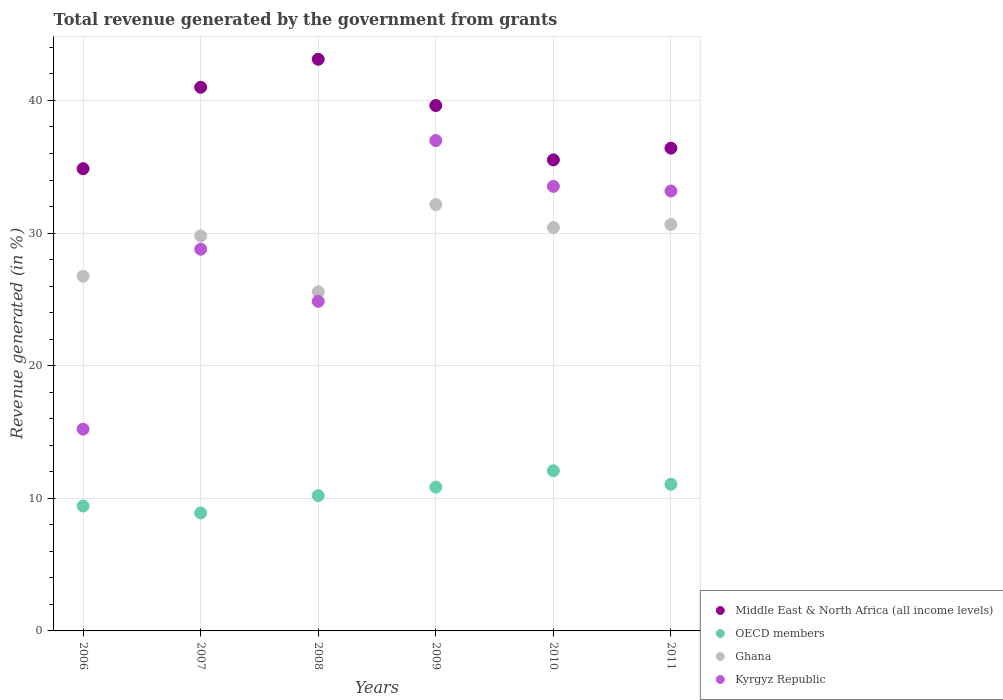How many different coloured dotlines are there?
Provide a short and direct response. 4. What is the total revenue generated in Kyrgyz Republic in 2009?
Your answer should be very brief. 36.97. Across all years, what is the maximum total revenue generated in OECD members?
Offer a very short reply. 12.08. Across all years, what is the minimum total revenue generated in Middle East & North Africa (all income levels)?
Give a very brief answer. 34.85. In which year was the total revenue generated in Ghana maximum?
Give a very brief answer. 2009. What is the total total revenue generated in Kyrgyz Republic in the graph?
Your answer should be compact. 172.52. What is the difference between the total revenue generated in Ghana in 2006 and that in 2007?
Offer a very short reply. -3.04. What is the difference between the total revenue generated in Kyrgyz Republic in 2008 and the total revenue generated in OECD members in 2009?
Your answer should be very brief. 14.01. What is the average total revenue generated in Middle East & North Africa (all income levels) per year?
Provide a succinct answer. 38.41. In the year 2007, what is the difference between the total revenue generated in Kyrgyz Republic and total revenue generated in Middle East & North Africa (all income levels)?
Offer a very short reply. -12.21. In how many years, is the total revenue generated in Kyrgyz Republic greater than 42 %?
Provide a succinct answer. 0. What is the ratio of the total revenue generated in OECD members in 2007 to that in 2011?
Make the answer very short. 0.8. Is the difference between the total revenue generated in Kyrgyz Republic in 2006 and 2010 greater than the difference between the total revenue generated in Middle East & North Africa (all income levels) in 2006 and 2010?
Offer a terse response. No. What is the difference between the highest and the second highest total revenue generated in Ghana?
Give a very brief answer. 1.5. What is the difference between the highest and the lowest total revenue generated in Middle East & North Africa (all income levels)?
Make the answer very short. 8.25. In how many years, is the total revenue generated in Middle East & North Africa (all income levels) greater than the average total revenue generated in Middle East & North Africa (all income levels) taken over all years?
Your answer should be compact. 3. Is the sum of the total revenue generated in OECD members in 2009 and 2011 greater than the maximum total revenue generated in Middle East & North Africa (all income levels) across all years?
Provide a succinct answer. No. Is it the case that in every year, the sum of the total revenue generated in Ghana and total revenue generated in Middle East & North Africa (all income levels)  is greater than the total revenue generated in OECD members?
Ensure brevity in your answer.  Yes. Is the total revenue generated in Ghana strictly greater than the total revenue generated in OECD members over the years?
Give a very brief answer. Yes. How many dotlines are there?
Offer a terse response. 4. How many years are there in the graph?
Make the answer very short. 6. What is the difference between two consecutive major ticks on the Y-axis?
Offer a very short reply. 10. Are the values on the major ticks of Y-axis written in scientific E-notation?
Ensure brevity in your answer.  No. What is the title of the graph?
Offer a very short reply. Total revenue generated by the government from grants. Does "Iceland" appear as one of the legend labels in the graph?
Ensure brevity in your answer.  No. What is the label or title of the X-axis?
Offer a very short reply. Years. What is the label or title of the Y-axis?
Your response must be concise. Revenue generated (in %). What is the Revenue generated (in %) of Middle East & North Africa (all income levels) in 2006?
Ensure brevity in your answer.  34.85. What is the Revenue generated (in %) of OECD members in 2006?
Offer a terse response. 9.41. What is the Revenue generated (in %) of Ghana in 2006?
Make the answer very short. 26.75. What is the Revenue generated (in %) of Kyrgyz Republic in 2006?
Keep it short and to the point. 15.21. What is the Revenue generated (in %) in Middle East & North Africa (all income levels) in 2007?
Your answer should be compact. 40.99. What is the Revenue generated (in %) in OECD members in 2007?
Your answer should be compact. 8.9. What is the Revenue generated (in %) in Ghana in 2007?
Offer a terse response. 29.79. What is the Revenue generated (in %) in Kyrgyz Republic in 2007?
Keep it short and to the point. 28.78. What is the Revenue generated (in %) of Middle East & North Africa (all income levels) in 2008?
Keep it short and to the point. 43.11. What is the Revenue generated (in %) in OECD members in 2008?
Offer a terse response. 10.2. What is the Revenue generated (in %) of Ghana in 2008?
Ensure brevity in your answer.  25.57. What is the Revenue generated (in %) of Kyrgyz Republic in 2008?
Provide a succinct answer. 24.85. What is the Revenue generated (in %) in Middle East & North Africa (all income levels) in 2009?
Provide a short and direct response. 39.62. What is the Revenue generated (in %) in OECD members in 2009?
Keep it short and to the point. 10.84. What is the Revenue generated (in %) in Ghana in 2009?
Give a very brief answer. 32.15. What is the Revenue generated (in %) of Kyrgyz Republic in 2009?
Your response must be concise. 36.97. What is the Revenue generated (in %) of Middle East & North Africa (all income levels) in 2010?
Offer a terse response. 35.52. What is the Revenue generated (in %) of OECD members in 2010?
Make the answer very short. 12.08. What is the Revenue generated (in %) in Ghana in 2010?
Give a very brief answer. 30.42. What is the Revenue generated (in %) of Kyrgyz Republic in 2010?
Make the answer very short. 33.52. What is the Revenue generated (in %) of Middle East & North Africa (all income levels) in 2011?
Provide a succinct answer. 36.4. What is the Revenue generated (in %) in OECD members in 2011?
Provide a succinct answer. 11.06. What is the Revenue generated (in %) in Ghana in 2011?
Provide a short and direct response. 30.65. What is the Revenue generated (in %) in Kyrgyz Republic in 2011?
Offer a terse response. 33.17. Across all years, what is the maximum Revenue generated (in %) of Middle East & North Africa (all income levels)?
Make the answer very short. 43.11. Across all years, what is the maximum Revenue generated (in %) of OECD members?
Give a very brief answer. 12.08. Across all years, what is the maximum Revenue generated (in %) in Ghana?
Provide a succinct answer. 32.15. Across all years, what is the maximum Revenue generated (in %) of Kyrgyz Republic?
Your response must be concise. 36.97. Across all years, what is the minimum Revenue generated (in %) of Middle East & North Africa (all income levels)?
Keep it short and to the point. 34.85. Across all years, what is the minimum Revenue generated (in %) of OECD members?
Keep it short and to the point. 8.9. Across all years, what is the minimum Revenue generated (in %) in Ghana?
Your response must be concise. 25.57. Across all years, what is the minimum Revenue generated (in %) of Kyrgyz Republic?
Your response must be concise. 15.21. What is the total Revenue generated (in %) of Middle East & North Africa (all income levels) in the graph?
Give a very brief answer. 230.49. What is the total Revenue generated (in %) in OECD members in the graph?
Offer a very short reply. 62.49. What is the total Revenue generated (in %) in Ghana in the graph?
Offer a very short reply. 175.32. What is the total Revenue generated (in %) of Kyrgyz Republic in the graph?
Give a very brief answer. 172.52. What is the difference between the Revenue generated (in %) in Middle East & North Africa (all income levels) in 2006 and that in 2007?
Keep it short and to the point. -6.14. What is the difference between the Revenue generated (in %) of OECD members in 2006 and that in 2007?
Provide a succinct answer. 0.51. What is the difference between the Revenue generated (in %) of Ghana in 2006 and that in 2007?
Offer a very short reply. -3.04. What is the difference between the Revenue generated (in %) in Kyrgyz Republic in 2006 and that in 2007?
Offer a very short reply. -13.57. What is the difference between the Revenue generated (in %) of Middle East & North Africa (all income levels) in 2006 and that in 2008?
Give a very brief answer. -8.25. What is the difference between the Revenue generated (in %) in OECD members in 2006 and that in 2008?
Your response must be concise. -0.79. What is the difference between the Revenue generated (in %) of Ghana in 2006 and that in 2008?
Make the answer very short. 1.17. What is the difference between the Revenue generated (in %) of Kyrgyz Republic in 2006 and that in 2008?
Provide a succinct answer. -9.64. What is the difference between the Revenue generated (in %) of Middle East & North Africa (all income levels) in 2006 and that in 2009?
Offer a very short reply. -4.76. What is the difference between the Revenue generated (in %) in OECD members in 2006 and that in 2009?
Your answer should be very brief. -1.43. What is the difference between the Revenue generated (in %) in Ghana in 2006 and that in 2009?
Provide a short and direct response. -5.4. What is the difference between the Revenue generated (in %) in Kyrgyz Republic in 2006 and that in 2009?
Your answer should be very brief. -21.76. What is the difference between the Revenue generated (in %) in Middle East & North Africa (all income levels) in 2006 and that in 2010?
Your answer should be compact. -0.67. What is the difference between the Revenue generated (in %) of OECD members in 2006 and that in 2010?
Your answer should be very brief. -2.66. What is the difference between the Revenue generated (in %) of Ghana in 2006 and that in 2010?
Give a very brief answer. -3.67. What is the difference between the Revenue generated (in %) in Kyrgyz Republic in 2006 and that in 2010?
Your answer should be very brief. -18.31. What is the difference between the Revenue generated (in %) in Middle East & North Africa (all income levels) in 2006 and that in 2011?
Make the answer very short. -1.55. What is the difference between the Revenue generated (in %) in OECD members in 2006 and that in 2011?
Provide a succinct answer. -1.64. What is the difference between the Revenue generated (in %) of Ghana in 2006 and that in 2011?
Your answer should be compact. -3.9. What is the difference between the Revenue generated (in %) in Kyrgyz Republic in 2006 and that in 2011?
Make the answer very short. -17.96. What is the difference between the Revenue generated (in %) of Middle East & North Africa (all income levels) in 2007 and that in 2008?
Make the answer very short. -2.11. What is the difference between the Revenue generated (in %) in OECD members in 2007 and that in 2008?
Your answer should be very brief. -1.3. What is the difference between the Revenue generated (in %) in Ghana in 2007 and that in 2008?
Offer a terse response. 4.21. What is the difference between the Revenue generated (in %) in Kyrgyz Republic in 2007 and that in 2008?
Ensure brevity in your answer.  3.93. What is the difference between the Revenue generated (in %) of Middle East & North Africa (all income levels) in 2007 and that in 2009?
Your answer should be very brief. 1.38. What is the difference between the Revenue generated (in %) of OECD members in 2007 and that in 2009?
Offer a terse response. -1.94. What is the difference between the Revenue generated (in %) in Ghana in 2007 and that in 2009?
Keep it short and to the point. -2.36. What is the difference between the Revenue generated (in %) of Kyrgyz Republic in 2007 and that in 2009?
Give a very brief answer. -8.19. What is the difference between the Revenue generated (in %) in Middle East & North Africa (all income levels) in 2007 and that in 2010?
Keep it short and to the point. 5.47. What is the difference between the Revenue generated (in %) of OECD members in 2007 and that in 2010?
Your response must be concise. -3.18. What is the difference between the Revenue generated (in %) in Ghana in 2007 and that in 2010?
Keep it short and to the point. -0.63. What is the difference between the Revenue generated (in %) of Kyrgyz Republic in 2007 and that in 2010?
Keep it short and to the point. -4.74. What is the difference between the Revenue generated (in %) in Middle East & North Africa (all income levels) in 2007 and that in 2011?
Keep it short and to the point. 4.59. What is the difference between the Revenue generated (in %) of OECD members in 2007 and that in 2011?
Keep it short and to the point. -2.16. What is the difference between the Revenue generated (in %) of Ghana in 2007 and that in 2011?
Provide a succinct answer. -0.86. What is the difference between the Revenue generated (in %) in Kyrgyz Republic in 2007 and that in 2011?
Your answer should be very brief. -4.39. What is the difference between the Revenue generated (in %) in Middle East & North Africa (all income levels) in 2008 and that in 2009?
Ensure brevity in your answer.  3.49. What is the difference between the Revenue generated (in %) of OECD members in 2008 and that in 2009?
Provide a succinct answer. -0.64. What is the difference between the Revenue generated (in %) of Ghana in 2008 and that in 2009?
Your response must be concise. -6.57. What is the difference between the Revenue generated (in %) in Kyrgyz Republic in 2008 and that in 2009?
Your response must be concise. -12.12. What is the difference between the Revenue generated (in %) in Middle East & North Africa (all income levels) in 2008 and that in 2010?
Offer a very short reply. 7.59. What is the difference between the Revenue generated (in %) in OECD members in 2008 and that in 2010?
Offer a very short reply. -1.88. What is the difference between the Revenue generated (in %) of Ghana in 2008 and that in 2010?
Your answer should be very brief. -4.84. What is the difference between the Revenue generated (in %) in Kyrgyz Republic in 2008 and that in 2010?
Ensure brevity in your answer.  -8.67. What is the difference between the Revenue generated (in %) of Middle East & North Africa (all income levels) in 2008 and that in 2011?
Provide a succinct answer. 6.7. What is the difference between the Revenue generated (in %) of OECD members in 2008 and that in 2011?
Provide a succinct answer. -0.86. What is the difference between the Revenue generated (in %) of Ghana in 2008 and that in 2011?
Provide a short and direct response. -5.07. What is the difference between the Revenue generated (in %) of Kyrgyz Republic in 2008 and that in 2011?
Give a very brief answer. -8.32. What is the difference between the Revenue generated (in %) of Middle East & North Africa (all income levels) in 2009 and that in 2010?
Ensure brevity in your answer.  4.1. What is the difference between the Revenue generated (in %) in OECD members in 2009 and that in 2010?
Offer a terse response. -1.24. What is the difference between the Revenue generated (in %) of Ghana in 2009 and that in 2010?
Give a very brief answer. 1.73. What is the difference between the Revenue generated (in %) of Kyrgyz Republic in 2009 and that in 2010?
Your response must be concise. 3.45. What is the difference between the Revenue generated (in %) in Middle East & North Africa (all income levels) in 2009 and that in 2011?
Keep it short and to the point. 3.21. What is the difference between the Revenue generated (in %) of OECD members in 2009 and that in 2011?
Your answer should be very brief. -0.22. What is the difference between the Revenue generated (in %) in Ghana in 2009 and that in 2011?
Offer a very short reply. 1.5. What is the difference between the Revenue generated (in %) in Kyrgyz Republic in 2009 and that in 2011?
Provide a short and direct response. 3.8. What is the difference between the Revenue generated (in %) in Middle East & North Africa (all income levels) in 2010 and that in 2011?
Offer a terse response. -0.88. What is the difference between the Revenue generated (in %) of OECD members in 2010 and that in 2011?
Provide a succinct answer. 1.02. What is the difference between the Revenue generated (in %) of Ghana in 2010 and that in 2011?
Your answer should be very brief. -0.23. What is the difference between the Revenue generated (in %) of Kyrgyz Republic in 2010 and that in 2011?
Ensure brevity in your answer.  0.35. What is the difference between the Revenue generated (in %) of Middle East & North Africa (all income levels) in 2006 and the Revenue generated (in %) of OECD members in 2007?
Your response must be concise. 25.95. What is the difference between the Revenue generated (in %) of Middle East & North Africa (all income levels) in 2006 and the Revenue generated (in %) of Ghana in 2007?
Offer a very short reply. 5.07. What is the difference between the Revenue generated (in %) of Middle East & North Africa (all income levels) in 2006 and the Revenue generated (in %) of Kyrgyz Republic in 2007?
Offer a very short reply. 6.07. What is the difference between the Revenue generated (in %) of OECD members in 2006 and the Revenue generated (in %) of Ghana in 2007?
Ensure brevity in your answer.  -20.37. What is the difference between the Revenue generated (in %) in OECD members in 2006 and the Revenue generated (in %) in Kyrgyz Republic in 2007?
Give a very brief answer. -19.37. What is the difference between the Revenue generated (in %) in Ghana in 2006 and the Revenue generated (in %) in Kyrgyz Republic in 2007?
Your response must be concise. -2.04. What is the difference between the Revenue generated (in %) of Middle East & North Africa (all income levels) in 2006 and the Revenue generated (in %) of OECD members in 2008?
Ensure brevity in your answer.  24.65. What is the difference between the Revenue generated (in %) of Middle East & North Africa (all income levels) in 2006 and the Revenue generated (in %) of Ghana in 2008?
Your answer should be very brief. 9.28. What is the difference between the Revenue generated (in %) of Middle East & North Africa (all income levels) in 2006 and the Revenue generated (in %) of Kyrgyz Republic in 2008?
Your answer should be compact. 10. What is the difference between the Revenue generated (in %) of OECD members in 2006 and the Revenue generated (in %) of Ghana in 2008?
Your answer should be compact. -16.16. What is the difference between the Revenue generated (in %) in OECD members in 2006 and the Revenue generated (in %) in Kyrgyz Republic in 2008?
Offer a terse response. -15.44. What is the difference between the Revenue generated (in %) of Ghana in 2006 and the Revenue generated (in %) of Kyrgyz Republic in 2008?
Provide a short and direct response. 1.9. What is the difference between the Revenue generated (in %) in Middle East & North Africa (all income levels) in 2006 and the Revenue generated (in %) in OECD members in 2009?
Make the answer very short. 24.01. What is the difference between the Revenue generated (in %) of Middle East & North Africa (all income levels) in 2006 and the Revenue generated (in %) of Ghana in 2009?
Make the answer very short. 2.71. What is the difference between the Revenue generated (in %) in Middle East & North Africa (all income levels) in 2006 and the Revenue generated (in %) in Kyrgyz Republic in 2009?
Ensure brevity in your answer.  -2.12. What is the difference between the Revenue generated (in %) of OECD members in 2006 and the Revenue generated (in %) of Ghana in 2009?
Make the answer very short. -22.73. What is the difference between the Revenue generated (in %) in OECD members in 2006 and the Revenue generated (in %) in Kyrgyz Republic in 2009?
Provide a succinct answer. -27.56. What is the difference between the Revenue generated (in %) of Ghana in 2006 and the Revenue generated (in %) of Kyrgyz Republic in 2009?
Your answer should be very brief. -10.23. What is the difference between the Revenue generated (in %) of Middle East & North Africa (all income levels) in 2006 and the Revenue generated (in %) of OECD members in 2010?
Make the answer very short. 22.78. What is the difference between the Revenue generated (in %) in Middle East & North Africa (all income levels) in 2006 and the Revenue generated (in %) in Ghana in 2010?
Offer a terse response. 4.44. What is the difference between the Revenue generated (in %) of Middle East & North Africa (all income levels) in 2006 and the Revenue generated (in %) of Kyrgyz Republic in 2010?
Ensure brevity in your answer.  1.33. What is the difference between the Revenue generated (in %) in OECD members in 2006 and the Revenue generated (in %) in Ghana in 2010?
Provide a short and direct response. -21. What is the difference between the Revenue generated (in %) of OECD members in 2006 and the Revenue generated (in %) of Kyrgyz Republic in 2010?
Give a very brief answer. -24.11. What is the difference between the Revenue generated (in %) in Ghana in 2006 and the Revenue generated (in %) in Kyrgyz Republic in 2010?
Offer a terse response. -6.77. What is the difference between the Revenue generated (in %) of Middle East & North Africa (all income levels) in 2006 and the Revenue generated (in %) of OECD members in 2011?
Offer a terse response. 23.8. What is the difference between the Revenue generated (in %) of Middle East & North Africa (all income levels) in 2006 and the Revenue generated (in %) of Ghana in 2011?
Your response must be concise. 4.21. What is the difference between the Revenue generated (in %) of Middle East & North Africa (all income levels) in 2006 and the Revenue generated (in %) of Kyrgyz Republic in 2011?
Provide a short and direct response. 1.68. What is the difference between the Revenue generated (in %) in OECD members in 2006 and the Revenue generated (in %) in Ghana in 2011?
Offer a terse response. -21.23. What is the difference between the Revenue generated (in %) of OECD members in 2006 and the Revenue generated (in %) of Kyrgyz Republic in 2011?
Give a very brief answer. -23.76. What is the difference between the Revenue generated (in %) of Ghana in 2006 and the Revenue generated (in %) of Kyrgyz Republic in 2011?
Your response must be concise. -6.43. What is the difference between the Revenue generated (in %) of Middle East & North Africa (all income levels) in 2007 and the Revenue generated (in %) of OECD members in 2008?
Ensure brevity in your answer.  30.79. What is the difference between the Revenue generated (in %) of Middle East & North Africa (all income levels) in 2007 and the Revenue generated (in %) of Ghana in 2008?
Offer a very short reply. 15.42. What is the difference between the Revenue generated (in %) in Middle East & North Africa (all income levels) in 2007 and the Revenue generated (in %) in Kyrgyz Republic in 2008?
Provide a succinct answer. 16.14. What is the difference between the Revenue generated (in %) in OECD members in 2007 and the Revenue generated (in %) in Ghana in 2008?
Your response must be concise. -16.68. What is the difference between the Revenue generated (in %) of OECD members in 2007 and the Revenue generated (in %) of Kyrgyz Republic in 2008?
Ensure brevity in your answer.  -15.95. What is the difference between the Revenue generated (in %) of Ghana in 2007 and the Revenue generated (in %) of Kyrgyz Republic in 2008?
Offer a terse response. 4.94. What is the difference between the Revenue generated (in %) in Middle East & North Africa (all income levels) in 2007 and the Revenue generated (in %) in OECD members in 2009?
Give a very brief answer. 30.15. What is the difference between the Revenue generated (in %) of Middle East & North Africa (all income levels) in 2007 and the Revenue generated (in %) of Ghana in 2009?
Your response must be concise. 8.85. What is the difference between the Revenue generated (in %) of Middle East & North Africa (all income levels) in 2007 and the Revenue generated (in %) of Kyrgyz Republic in 2009?
Ensure brevity in your answer.  4.02. What is the difference between the Revenue generated (in %) of OECD members in 2007 and the Revenue generated (in %) of Ghana in 2009?
Provide a succinct answer. -23.25. What is the difference between the Revenue generated (in %) of OECD members in 2007 and the Revenue generated (in %) of Kyrgyz Republic in 2009?
Your answer should be compact. -28.08. What is the difference between the Revenue generated (in %) of Ghana in 2007 and the Revenue generated (in %) of Kyrgyz Republic in 2009?
Your answer should be very brief. -7.19. What is the difference between the Revenue generated (in %) of Middle East & North Africa (all income levels) in 2007 and the Revenue generated (in %) of OECD members in 2010?
Offer a terse response. 28.91. What is the difference between the Revenue generated (in %) in Middle East & North Africa (all income levels) in 2007 and the Revenue generated (in %) in Ghana in 2010?
Make the answer very short. 10.58. What is the difference between the Revenue generated (in %) in Middle East & North Africa (all income levels) in 2007 and the Revenue generated (in %) in Kyrgyz Republic in 2010?
Your answer should be very brief. 7.47. What is the difference between the Revenue generated (in %) in OECD members in 2007 and the Revenue generated (in %) in Ghana in 2010?
Your answer should be very brief. -21.52. What is the difference between the Revenue generated (in %) of OECD members in 2007 and the Revenue generated (in %) of Kyrgyz Republic in 2010?
Ensure brevity in your answer.  -24.62. What is the difference between the Revenue generated (in %) of Ghana in 2007 and the Revenue generated (in %) of Kyrgyz Republic in 2010?
Your response must be concise. -3.73. What is the difference between the Revenue generated (in %) in Middle East & North Africa (all income levels) in 2007 and the Revenue generated (in %) in OECD members in 2011?
Keep it short and to the point. 29.94. What is the difference between the Revenue generated (in %) of Middle East & North Africa (all income levels) in 2007 and the Revenue generated (in %) of Ghana in 2011?
Provide a succinct answer. 10.35. What is the difference between the Revenue generated (in %) in Middle East & North Africa (all income levels) in 2007 and the Revenue generated (in %) in Kyrgyz Republic in 2011?
Keep it short and to the point. 7.82. What is the difference between the Revenue generated (in %) in OECD members in 2007 and the Revenue generated (in %) in Ghana in 2011?
Offer a very short reply. -21.75. What is the difference between the Revenue generated (in %) of OECD members in 2007 and the Revenue generated (in %) of Kyrgyz Republic in 2011?
Provide a succinct answer. -24.27. What is the difference between the Revenue generated (in %) of Ghana in 2007 and the Revenue generated (in %) of Kyrgyz Republic in 2011?
Your response must be concise. -3.39. What is the difference between the Revenue generated (in %) in Middle East & North Africa (all income levels) in 2008 and the Revenue generated (in %) in OECD members in 2009?
Your answer should be compact. 32.26. What is the difference between the Revenue generated (in %) in Middle East & North Africa (all income levels) in 2008 and the Revenue generated (in %) in Ghana in 2009?
Make the answer very short. 10.96. What is the difference between the Revenue generated (in %) of Middle East & North Africa (all income levels) in 2008 and the Revenue generated (in %) of Kyrgyz Republic in 2009?
Keep it short and to the point. 6.13. What is the difference between the Revenue generated (in %) of OECD members in 2008 and the Revenue generated (in %) of Ghana in 2009?
Your answer should be compact. -21.95. What is the difference between the Revenue generated (in %) in OECD members in 2008 and the Revenue generated (in %) in Kyrgyz Republic in 2009?
Provide a succinct answer. -26.77. What is the difference between the Revenue generated (in %) in Ghana in 2008 and the Revenue generated (in %) in Kyrgyz Republic in 2009?
Provide a succinct answer. -11.4. What is the difference between the Revenue generated (in %) in Middle East & North Africa (all income levels) in 2008 and the Revenue generated (in %) in OECD members in 2010?
Your answer should be very brief. 31.03. What is the difference between the Revenue generated (in %) of Middle East & North Africa (all income levels) in 2008 and the Revenue generated (in %) of Ghana in 2010?
Offer a very short reply. 12.69. What is the difference between the Revenue generated (in %) in Middle East & North Africa (all income levels) in 2008 and the Revenue generated (in %) in Kyrgyz Republic in 2010?
Your answer should be very brief. 9.58. What is the difference between the Revenue generated (in %) in OECD members in 2008 and the Revenue generated (in %) in Ghana in 2010?
Your answer should be compact. -20.22. What is the difference between the Revenue generated (in %) of OECD members in 2008 and the Revenue generated (in %) of Kyrgyz Republic in 2010?
Your response must be concise. -23.32. What is the difference between the Revenue generated (in %) in Ghana in 2008 and the Revenue generated (in %) in Kyrgyz Republic in 2010?
Your answer should be very brief. -7.95. What is the difference between the Revenue generated (in %) of Middle East & North Africa (all income levels) in 2008 and the Revenue generated (in %) of OECD members in 2011?
Make the answer very short. 32.05. What is the difference between the Revenue generated (in %) of Middle East & North Africa (all income levels) in 2008 and the Revenue generated (in %) of Ghana in 2011?
Keep it short and to the point. 12.46. What is the difference between the Revenue generated (in %) of Middle East & North Africa (all income levels) in 2008 and the Revenue generated (in %) of Kyrgyz Republic in 2011?
Your response must be concise. 9.93. What is the difference between the Revenue generated (in %) of OECD members in 2008 and the Revenue generated (in %) of Ghana in 2011?
Your answer should be compact. -20.45. What is the difference between the Revenue generated (in %) in OECD members in 2008 and the Revenue generated (in %) in Kyrgyz Republic in 2011?
Provide a succinct answer. -22.97. What is the difference between the Revenue generated (in %) in Ghana in 2008 and the Revenue generated (in %) in Kyrgyz Republic in 2011?
Offer a very short reply. -7.6. What is the difference between the Revenue generated (in %) in Middle East & North Africa (all income levels) in 2009 and the Revenue generated (in %) in OECD members in 2010?
Your answer should be very brief. 27.54. What is the difference between the Revenue generated (in %) in Middle East & North Africa (all income levels) in 2009 and the Revenue generated (in %) in Ghana in 2010?
Your response must be concise. 9.2. What is the difference between the Revenue generated (in %) of Middle East & North Africa (all income levels) in 2009 and the Revenue generated (in %) of Kyrgyz Republic in 2010?
Offer a terse response. 6.09. What is the difference between the Revenue generated (in %) in OECD members in 2009 and the Revenue generated (in %) in Ghana in 2010?
Offer a very short reply. -19.58. What is the difference between the Revenue generated (in %) in OECD members in 2009 and the Revenue generated (in %) in Kyrgyz Republic in 2010?
Ensure brevity in your answer.  -22.68. What is the difference between the Revenue generated (in %) in Ghana in 2009 and the Revenue generated (in %) in Kyrgyz Republic in 2010?
Provide a short and direct response. -1.37. What is the difference between the Revenue generated (in %) of Middle East & North Africa (all income levels) in 2009 and the Revenue generated (in %) of OECD members in 2011?
Your answer should be compact. 28.56. What is the difference between the Revenue generated (in %) in Middle East & North Africa (all income levels) in 2009 and the Revenue generated (in %) in Ghana in 2011?
Your answer should be compact. 8.97. What is the difference between the Revenue generated (in %) of Middle East & North Africa (all income levels) in 2009 and the Revenue generated (in %) of Kyrgyz Republic in 2011?
Provide a short and direct response. 6.44. What is the difference between the Revenue generated (in %) in OECD members in 2009 and the Revenue generated (in %) in Ghana in 2011?
Provide a succinct answer. -19.81. What is the difference between the Revenue generated (in %) of OECD members in 2009 and the Revenue generated (in %) of Kyrgyz Republic in 2011?
Make the answer very short. -22.33. What is the difference between the Revenue generated (in %) in Ghana in 2009 and the Revenue generated (in %) in Kyrgyz Republic in 2011?
Give a very brief answer. -1.03. What is the difference between the Revenue generated (in %) of Middle East & North Africa (all income levels) in 2010 and the Revenue generated (in %) of OECD members in 2011?
Your answer should be very brief. 24.46. What is the difference between the Revenue generated (in %) in Middle East & North Africa (all income levels) in 2010 and the Revenue generated (in %) in Ghana in 2011?
Offer a terse response. 4.87. What is the difference between the Revenue generated (in %) of Middle East & North Africa (all income levels) in 2010 and the Revenue generated (in %) of Kyrgyz Republic in 2011?
Keep it short and to the point. 2.35. What is the difference between the Revenue generated (in %) in OECD members in 2010 and the Revenue generated (in %) in Ghana in 2011?
Make the answer very short. -18.57. What is the difference between the Revenue generated (in %) in OECD members in 2010 and the Revenue generated (in %) in Kyrgyz Republic in 2011?
Give a very brief answer. -21.1. What is the difference between the Revenue generated (in %) of Ghana in 2010 and the Revenue generated (in %) of Kyrgyz Republic in 2011?
Give a very brief answer. -2.76. What is the average Revenue generated (in %) of Middle East & North Africa (all income levels) per year?
Keep it short and to the point. 38.41. What is the average Revenue generated (in %) in OECD members per year?
Provide a succinct answer. 10.41. What is the average Revenue generated (in %) in Ghana per year?
Keep it short and to the point. 29.22. What is the average Revenue generated (in %) of Kyrgyz Republic per year?
Give a very brief answer. 28.75. In the year 2006, what is the difference between the Revenue generated (in %) in Middle East & North Africa (all income levels) and Revenue generated (in %) in OECD members?
Provide a succinct answer. 25.44. In the year 2006, what is the difference between the Revenue generated (in %) of Middle East & North Africa (all income levels) and Revenue generated (in %) of Ghana?
Offer a terse response. 8.11. In the year 2006, what is the difference between the Revenue generated (in %) in Middle East & North Africa (all income levels) and Revenue generated (in %) in Kyrgyz Republic?
Provide a succinct answer. 19.64. In the year 2006, what is the difference between the Revenue generated (in %) in OECD members and Revenue generated (in %) in Ghana?
Provide a succinct answer. -17.33. In the year 2006, what is the difference between the Revenue generated (in %) of OECD members and Revenue generated (in %) of Kyrgyz Republic?
Make the answer very short. -5.8. In the year 2006, what is the difference between the Revenue generated (in %) of Ghana and Revenue generated (in %) of Kyrgyz Republic?
Ensure brevity in your answer.  11.53. In the year 2007, what is the difference between the Revenue generated (in %) in Middle East & North Africa (all income levels) and Revenue generated (in %) in OECD members?
Your response must be concise. 32.09. In the year 2007, what is the difference between the Revenue generated (in %) of Middle East & North Africa (all income levels) and Revenue generated (in %) of Ghana?
Offer a terse response. 11.21. In the year 2007, what is the difference between the Revenue generated (in %) in Middle East & North Africa (all income levels) and Revenue generated (in %) in Kyrgyz Republic?
Offer a terse response. 12.21. In the year 2007, what is the difference between the Revenue generated (in %) in OECD members and Revenue generated (in %) in Ghana?
Your response must be concise. -20.89. In the year 2007, what is the difference between the Revenue generated (in %) in OECD members and Revenue generated (in %) in Kyrgyz Republic?
Your answer should be compact. -19.89. In the year 2008, what is the difference between the Revenue generated (in %) in Middle East & North Africa (all income levels) and Revenue generated (in %) in OECD members?
Make the answer very short. 32.9. In the year 2008, what is the difference between the Revenue generated (in %) of Middle East & North Africa (all income levels) and Revenue generated (in %) of Ghana?
Your response must be concise. 17.53. In the year 2008, what is the difference between the Revenue generated (in %) of Middle East & North Africa (all income levels) and Revenue generated (in %) of Kyrgyz Republic?
Make the answer very short. 18.25. In the year 2008, what is the difference between the Revenue generated (in %) in OECD members and Revenue generated (in %) in Ghana?
Your answer should be very brief. -15.37. In the year 2008, what is the difference between the Revenue generated (in %) of OECD members and Revenue generated (in %) of Kyrgyz Republic?
Your response must be concise. -14.65. In the year 2008, what is the difference between the Revenue generated (in %) in Ghana and Revenue generated (in %) in Kyrgyz Republic?
Ensure brevity in your answer.  0.72. In the year 2009, what is the difference between the Revenue generated (in %) in Middle East & North Africa (all income levels) and Revenue generated (in %) in OECD members?
Your answer should be very brief. 28.78. In the year 2009, what is the difference between the Revenue generated (in %) of Middle East & North Africa (all income levels) and Revenue generated (in %) of Ghana?
Provide a succinct answer. 7.47. In the year 2009, what is the difference between the Revenue generated (in %) in Middle East & North Africa (all income levels) and Revenue generated (in %) in Kyrgyz Republic?
Your answer should be compact. 2.64. In the year 2009, what is the difference between the Revenue generated (in %) in OECD members and Revenue generated (in %) in Ghana?
Provide a short and direct response. -21.31. In the year 2009, what is the difference between the Revenue generated (in %) in OECD members and Revenue generated (in %) in Kyrgyz Republic?
Provide a succinct answer. -26.13. In the year 2009, what is the difference between the Revenue generated (in %) of Ghana and Revenue generated (in %) of Kyrgyz Republic?
Give a very brief answer. -4.83. In the year 2010, what is the difference between the Revenue generated (in %) of Middle East & North Africa (all income levels) and Revenue generated (in %) of OECD members?
Offer a terse response. 23.44. In the year 2010, what is the difference between the Revenue generated (in %) of Middle East & North Africa (all income levels) and Revenue generated (in %) of Ghana?
Provide a short and direct response. 5.1. In the year 2010, what is the difference between the Revenue generated (in %) of Middle East & North Africa (all income levels) and Revenue generated (in %) of Kyrgyz Republic?
Your answer should be very brief. 2. In the year 2010, what is the difference between the Revenue generated (in %) in OECD members and Revenue generated (in %) in Ghana?
Keep it short and to the point. -18.34. In the year 2010, what is the difference between the Revenue generated (in %) of OECD members and Revenue generated (in %) of Kyrgyz Republic?
Make the answer very short. -21.44. In the year 2010, what is the difference between the Revenue generated (in %) in Ghana and Revenue generated (in %) in Kyrgyz Republic?
Provide a succinct answer. -3.1. In the year 2011, what is the difference between the Revenue generated (in %) in Middle East & North Africa (all income levels) and Revenue generated (in %) in OECD members?
Provide a short and direct response. 25.35. In the year 2011, what is the difference between the Revenue generated (in %) of Middle East & North Africa (all income levels) and Revenue generated (in %) of Ghana?
Your answer should be compact. 5.76. In the year 2011, what is the difference between the Revenue generated (in %) of Middle East & North Africa (all income levels) and Revenue generated (in %) of Kyrgyz Republic?
Your answer should be very brief. 3.23. In the year 2011, what is the difference between the Revenue generated (in %) in OECD members and Revenue generated (in %) in Ghana?
Keep it short and to the point. -19.59. In the year 2011, what is the difference between the Revenue generated (in %) in OECD members and Revenue generated (in %) in Kyrgyz Republic?
Keep it short and to the point. -22.12. In the year 2011, what is the difference between the Revenue generated (in %) in Ghana and Revenue generated (in %) in Kyrgyz Republic?
Offer a very short reply. -2.53. What is the ratio of the Revenue generated (in %) of Middle East & North Africa (all income levels) in 2006 to that in 2007?
Keep it short and to the point. 0.85. What is the ratio of the Revenue generated (in %) in OECD members in 2006 to that in 2007?
Provide a succinct answer. 1.06. What is the ratio of the Revenue generated (in %) in Ghana in 2006 to that in 2007?
Your response must be concise. 0.9. What is the ratio of the Revenue generated (in %) in Kyrgyz Republic in 2006 to that in 2007?
Keep it short and to the point. 0.53. What is the ratio of the Revenue generated (in %) in Middle East & North Africa (all income levels) in 2006 to that in 2008?
Offer a very short reply. 0.81. What is the ratio of the Revenue generated (in %) in OECD members in 2006 to that in 2008?
Keep it short and to the point. 0.92. What is the ratio of the Revenue generated (in %) in Ghana in 2006 to that in 2008?
Keep it short and to the point. 1.05. What is the ratio of the Revenue generated (in %) in Kyrgyz Republic in 2006 to that in 2008?
Your answer should be very brief. 0.61. What is the ratio of the Revenue generated (in %) of Middle East & North Africa (all income levels) in 2006 to that in 2009?
Your response must be concise. 0.88. What is the ratio of the Revenue generated (in %) in OECD members in 2006 to that in 2009?
Offer a very short reply. 0.87. What is the ratio of the Revenue generated (in %) of Ghana in 2006 to that in 2009?
Provide a short and direct response. 0.83. What is the ratio of the Revenue generated (in %) in Kyrgyz Republic in 2006 to that in 2009?
Provide a short and direct response. 0.41. What is the ratio of the Revenue generated (in %) in Middle East & North Africa (all income levels) in 2006 to that in 2010?
Your response must be concise. 0.98. What is the ratio of the Revenue generated (in %) of OECD members in 2006 to that in 2010?
Offer a terse response. 0.78. What is the ratio of the Revenue generated (in %) in Ghana in 2006 to that in 2010?
Give a very brief answer. 0.88. What is the ratio of the Revenue generated (in %) of Kyrgyz Republic in 2006 to that in 2010?
Provide a succinct answer. 0.45. What is the ratio of the Revenue generated (in %) in Middle East & North Africa (all income levels) in 2006 to that in 2011?
Keep it short and to the point. 0.96. What is the ratio of the Revenue generated (in %) of OECD members in 2006 to that in 2011?
Give a very brief answer. 0.85. What is the ratio of the Revenue generated (in %) in Ghana in 2006 to that in 2011?
Provide a short and direct response. 0.87. What is the ratio of the Revenue generated (in %) in Kyrgyz Republic in 2006 to that in 2011?
Offer a terse response. 0.46. What is the ratio of the Revenue generated (in %) in Middle East & North Africa (all income levels) in 2007 to that in 2008?
Your answer should be compact. 0.95. What is the ratio of the Revenue generated (in %) in OECD members in 2007 to that in 2008?
Offer a terse response. 0.87. What is the ratio of the Revenue generated (in %) in Ghana in 2007 to that in 2008?
Your response must be concise. 1.16. What is the ratio of the Revenue generated (in %) in Kyrgyz Republic in 2007 to that in 2008?
Ensure brevity in your answer.  1.16. What is the ratio of the Revenue generated (in %) in Middle East & North Africa (all income levels) in 2007 to that in 2009?
Give a very brief answer. 1.03. What is the ratio of the Revenue generated (in %) of OECD members in 2007 to that in 2009?
Your answer should be very brief. 0.82. What is the ratio of the Revenue generated (in %) in Ghana in 2007 to that in 2009?
Ensure brevity in your answer.  0.93. What is the ratio of the Revenue generated (in %) in Kyrgyz Republic in 2007 to that in 2009?
Provide a succinct answer. 0.78. What is the ratio of the Revenue generated (in %) of Middle East & North Africa (all income levels) in 2007 to that in 2010?
Provide a succinct answer. 1.15. What is the ratio of the Revenue generated (in %) in OECD members in 2007 to that in 2010?
Your answer should be compact. 0.74. What is the ratio of the Revenue generated (in %) in Ghana in 2007 to that in 2010?
Keep it short and to the point. 0.98. What is the ratio of the Revenue generated (in %) of Kyrgyz Republic in 2007 to that in 2010?
Your response must be concise. 0.86. What is the ratio of the Revenue generated (in %) of Middle East & North Africa (all income levels) in 2007 to that in 2011?
Keep it short and to the point. 1.13. What is the ratio of the Revenue generated (in %) in OECD members in 2007 to that in 2011?
Give a very brief answer. 0.8. What is the ratio of the Revenue generated (in %) of Ghana in 2007 to that in 2011?
Offer a terse response. 0.97. What is the ratio of the Revenue generated (in %) in Kyrgyz Republic in 2007 to that in 2011?
Give a very brief answer. 0.87. What is the ratio of the Revenue generated (in %) in Middle East & North Africa (all income levels) in 2008 to that in 2009?
Keep it short and to the point. 1.09. What is the ratio of the Revenue generated (in %) in OECD members in 2008 to that in 2009?
Provide a short and direct response. 0.94. What is the ratio of the Revenue generated (in %) in Ghana in 2008 to that in 2009?
Offer a very short reply. 0.8. What is the ratio of the Revenue generated (in %) in Kyrgyz Republic in 2008 to that in 2009?
Keep it short and to the point. 0.67. What is the ratio of the Revenue generated (in %) in Middle East & North Africa (all income levels) in 2008 to that in 2010?
Your answer should be compact. 1.21. What is the ratio of the Revenue generated (in %) of OECD members in 2008 to that in 2010?
Your answer should be compact. 0.84. What is the ratio of the Revenue generated (in %) of Ghana in 2008 to that in 2010?
Offer a terse response. 0.84. What is the ratio of the Revenue generated (in %) of Kyrgyz Republic in 2008 to that in 2010?
Give a very brief answer. 0.74. What is the ratio of the Revenue generated (in %) in Middle East & North Africa (all income levels) in 2008 to that in 2011?
Provide a short and direct response. 1.18. What is the ratio of the Revenue generated (in %) in OECD members in 2008 to that in 2011?
Your response must be concise. 0.92. What is the ratio of the Revenue generated (in %) of Ghana in 2008 to that in 2011?
Your answer should be compact. 0.83. What is the ratio of the Revenue generated (in %) in Kyrgyz Republic in 2008 to that in 2011?
Offer a very short reply. 0.75. What is the ratio of the Revenue generated (in %) in Middle East & North Africa (all income levels) in 2009 to that in 2010?
Your response must be concise. 1.12. What is the ratio of the Revenue generated (in %) in OECD members in 2009 to that in 2010?
Offer a very short reply. 0.9. What is the ratio of the Revenue generated (in %) in Ghana in 2009 to that in 2010?
Provide a succinct answer. 1.06. What is the ratio of the Revenue generated (in %) in Kyrgyz Republic in 2009 to that in 2010?
Ensure brevity in your answer.  1.1. What is the ratio of the Revenue generated (in %) of Middle East & North Africa (all income levels) in 2009 to that in 2011?
Provide a succinct answer. 1.09. What is the ratio of the Revenue generated (in %) in OECD members in 2009 to that in 2011?
Give a very brief answer. 0.98. What is the ratio of the Revenue generated (in %) of Ghana in 2009 to that in 2011?
Offer a very short reply. 1.05. What is the ratio of the Revenue generated (in %) in Kyrgyz Republic in 2009 to that in 2011?
Your answer should be compact. 1.11. What is the ratio of the Revenue generated (in %) of Middle East & North Africa (all income levels) in 2010 to that in 2011?
Provide a short and direct response. 0.98. What is the ratio of the Revenue generated (in %) in OECD members in 2010 to that in 2011?
Make the answer very short. 1.09. What is the ratio of the Revenue generated (in %) in Kyrgyz Republic in 2010 to that in 2011?
Provide a succinct answer. 1.01. What is the difference between the highest and the second highest Revenue generated (in %) in Middle East & North Africa (all income levels)?
Give a very brief answer. 2.11. What is the difference between the highest and the second highest Revenue generated (in %) of OECD members?
Your answer should be compact. 1.02. What is the difference between the highest and the second highest Revenue generated (in %) of Ghana?
Your response must be concise. 1.5. What is the difference between the highest and the second highest Revenue generated (in %) of Kyrgyz Republic?
Your response must be concise. 3.45. What is the difference between the highest and the lowest Revenue generated (in %) in Middle East & North Africa (all income levels)?
Offer a very short reply. 8.25. What is the difference between the highest and the lowest Revenue generated (in %) of OECD members?
Offer a terse response. 3.18. What is the difference between the highest and the lowest Revenue generated (in %) of Ghana?
Offer a very short reply. 6.57. What is the difference between the highest and the lowest Revenue generated (in %) in Kyrgyz Republic?
Provide a short and direct response. 21.76. 